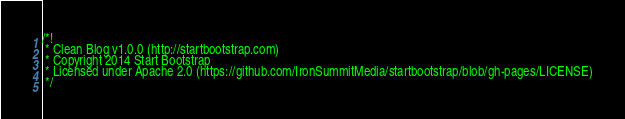<code> <loc_0><loc_0><loc_500><loc_500><_CSS_>/*!
 * Clean Blog v1.0.0 (http://startbootstrap.com)
 * Copyright 2014 Start Bootstrap
 * Licensed under Apache 2.0 (https://github.com/IronSummitMedia/startbootstrap/blob/gh-pages/LICENSE)
 */
</code> 